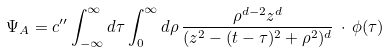<formula> <loc_0><loc_0><loc_500><loc_500>\Psi _ { A } = c ^ { \prime \prime } \int _ { - \infty } ^ { \infty } d \tau \int _ { 0 } ^ { \infty } d \rho \, \frac { \rho ^ { d - 2 } z ^ { d } } { ( z ^ { 2 } - ( t - \tau ) ^ { 2 } + \rho ^ { 2 } ) ^ { d } } \, \cdot \, \phi ( \tau )</formula> 